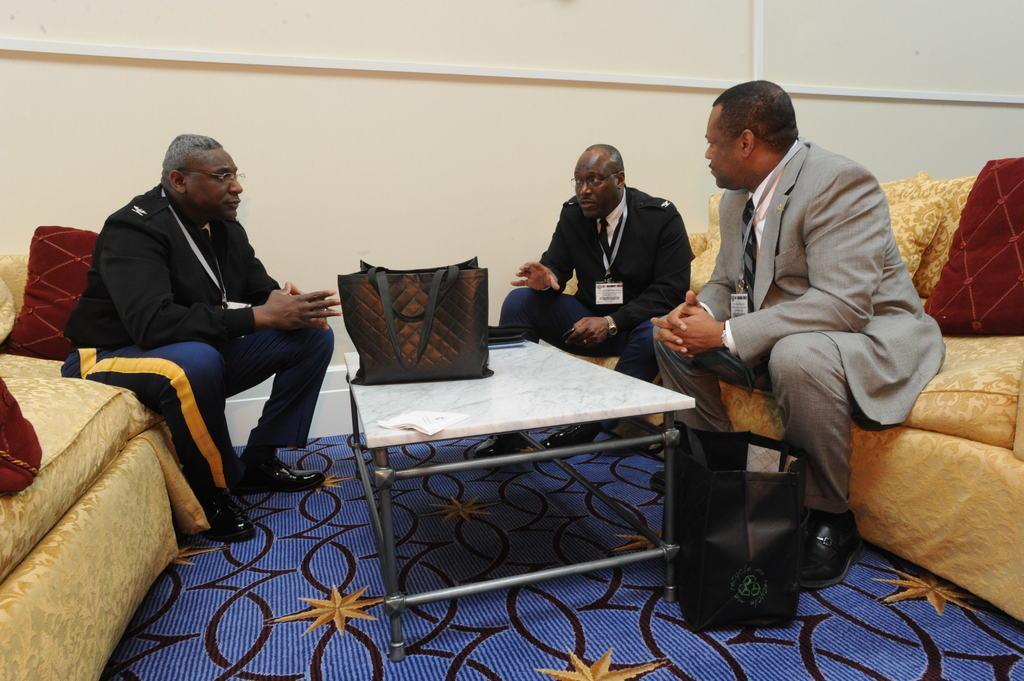How would you summarize this image in a sentence or two? This picture shows three men seated and speaking to each other on a sofa and we see a handbag on the table can we see couple of pillows 